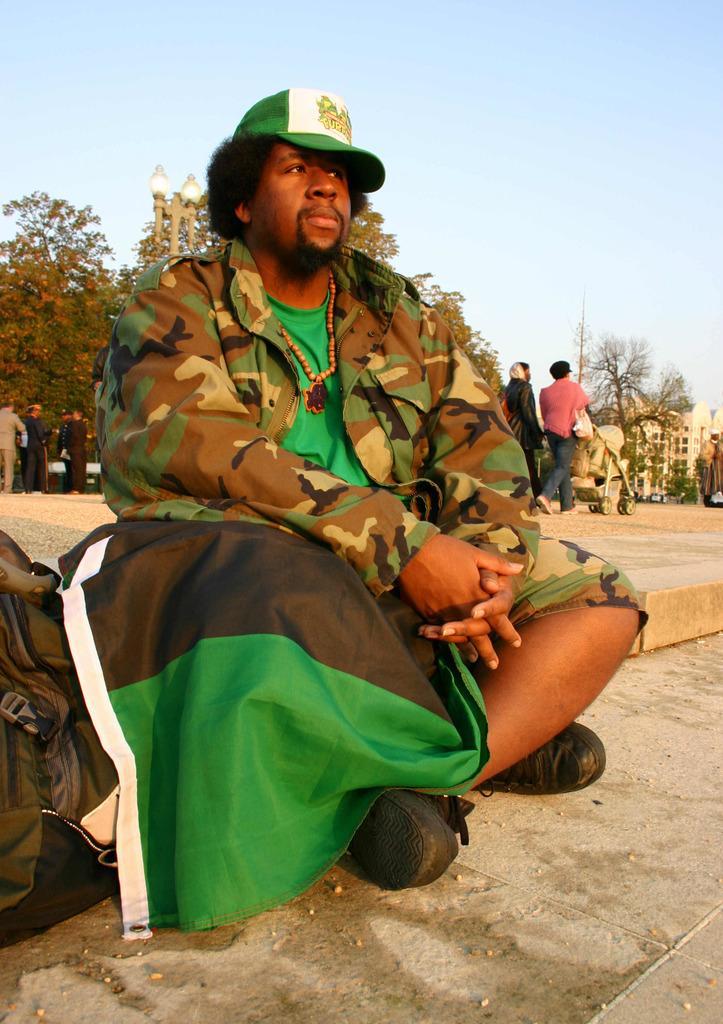Please provide a concise description of this image. In the picture there is a man sitting on the ground and behind him there are few other people, behind those people there are few trees and on the right side there are some buildings. 